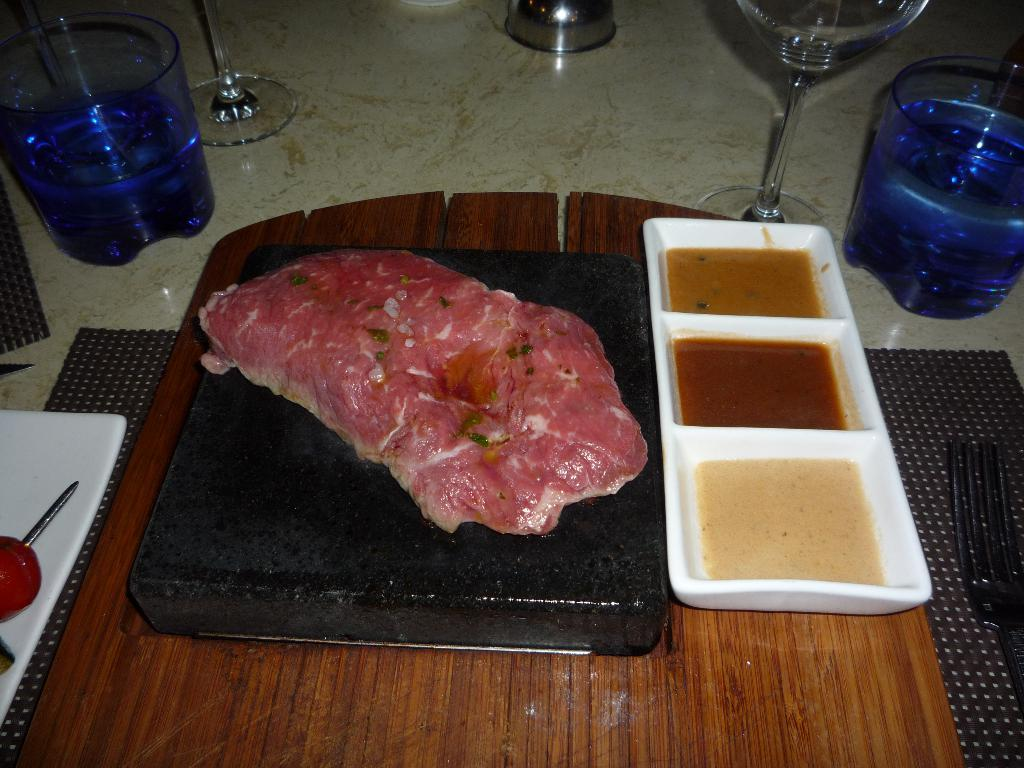What type of food is present in the image? There is meat in the image. What accompanies the meat in the image? There are sauces in the image. What beverages are visible in the image? There are glasses filled with drinks in the image. How many children are playing with the doll in the image? There are no children or dolls present in the image; it only features meat, sauces, and glasses filled with drinks. 